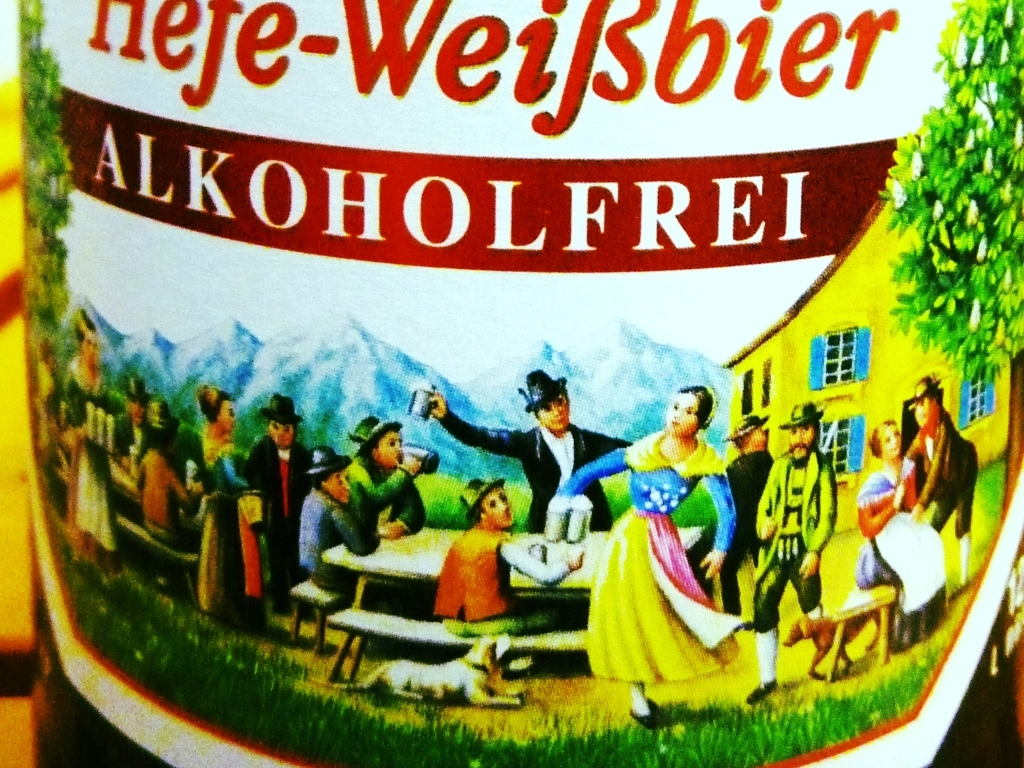Is the text in the image clear?
A. Blurry text.
B. Clear text.
C. Illegible text.
Answer with the option's letter from the given choices directly.
 B. 